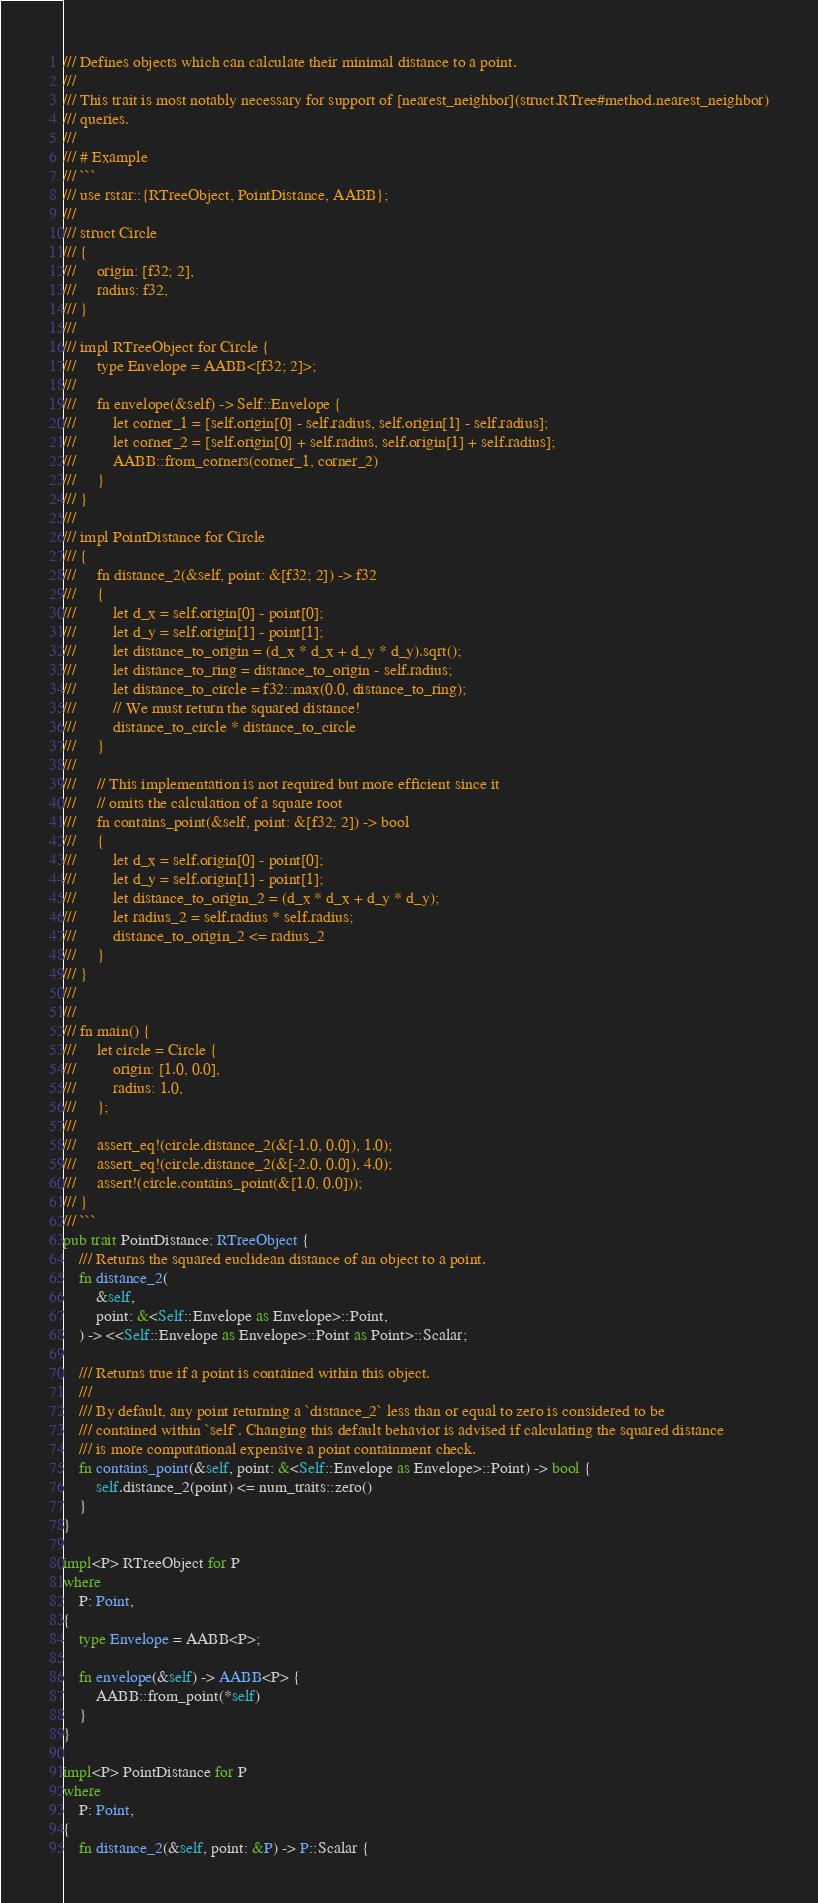Convert code to text. <code><loc_0><loc_0><loc_500><loc_500><_Rust_>/// Defines objects which can calculate their minimal distance to a point.
///
/// This trait is most notably necessary for support of [nearest_neighbor](struct.RTree#method.nearest_neighbor)
/// queries.
///
/// # Example
/// ```
/// use rstar::{RTreeObject, PointDistance, AABB};
///
/// struct Circle
/// {
///     origin: [f32; 2],
///     radius: f32,
/// }
///
/// impl RTreeObject for Circle {
///     type Envelope = AABB<[f32; 2]>;
///     
///     fn envelope(&self) -> Self::Envelope {
///         let corner_1 = [self.origin[0] - self.radius, self.origin[1] - self.radius];
///         let corner_2 = [self.origin[0] + self.radius, self.origin[1] + self.radius];
///         AABB::from_corners(corner_1, corner_2)
///     }
/// }
///
/// impl PointDistance for Circle
/// {
///     fn distance_2(&self, point: &[f32; 2]) -> f32
///     {
///         let d_x = self.origin[0] - point[0];
///         let d_y = self.origin[1] - point[1];
///         let distance_to_origin = (d_x * d_x + d_y * d_y).sqrt();
///         let distance_to_ring = distance_to_origin - self.radius;
///         let distance_to_circle = f32::max(0.0, distance_to_ring);
///         // We must return the squared distance!
///         distance_to_circle * distance_to_circle
///     }
///
///     // This implementation is not required but more efficient since it
///     // omits the calculation of a square root
///     fn contains_point(&self, point: &[f32; 2]) -> bool
///     {
///         let d_x = self.origin[0] - point[0];
///         let d_y = self.origin[1] - point[1];
///         let distance_to_origin_2 = (d_x * d_x + d_y * d_y);
///         let radius_2 = self.radius * self.radius;
///         distance_to_origin_2 <= radius_2
///     }
/// }
///
///
/// fn main() {
///     let circle = Circle {
///         origin: [1.0, 0.0],
///         radius: 1.0,
///     };
///
///     assert_eq!(circle.distance_2(&[-1.0, 0.0]), 1.0);
///     assert_eq!(circle.distance_2(&[-2.0, 0.0]), 4.0);
///     assert!(circle.contains_point(&[1.0, 0.0]));
/// }
/// ```
pub trait PointDistance: RTreeObject {
    /// Returns the squared euclidean distance of an object to a point.
    fn distance_2(
        &self,
        point: &<Self::Envelope as Envelope>::Point,
    ) -> <<Self::Envelope as Envelope>::Point as Point>::Scalar;

    /// Returns true if a point is contained within this object.
    ///
    /// By default, any point returning a `distance_2` less than or equal to zero is considered to be
    /// contained within `self`. Changing this default behavior is advised if calculating the squared distance
    /// is more computational expensive a point containment check.
    fn contains_point(&self, point: &<Self::Envelope as Envelope>::Point) -> bool {
        self.distance_2(point) <= num_traits::zero()
    }
}

impl<P> RTreeObject for P
where
    P: Point,
{
    type Envelope = AABB<P>;

    fn envelope(&self) -> AABB<P> {
        AABB::from_point(*self)
    }
}

impl<P> PointDistance for P
where
    P: Point,
{
    fn distance_2(&self, point: &P) -> P::Scalar {</code> 